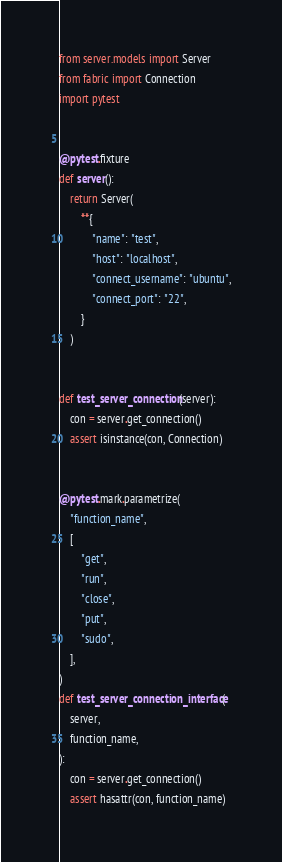<code> <loc_0><loc_0><loc_500><loc_500><_Python_>from server.models import Server
from fabric import Connection
import pytest


@pytest.fixture
def server():
    return Server(
        **{
            "name": "test",
            "host": "localhost",
            "connect_username": "ubuntu",
            "connect_port": "22",
        }
    )


def test_server_connection(server):
    con = server.get_connection()
    assert isinstance(con, Connection)


@pytest.mark.parametrize(
    "function_name",
    [
        "get",
        "run",
        "close",
        "put",
        "sudo",
    ],
)
def test_server_connection_interface(
    server,
    function_name,
):
    con = server.get_connection()
    assert hasattr(con, function_name)
</code> 